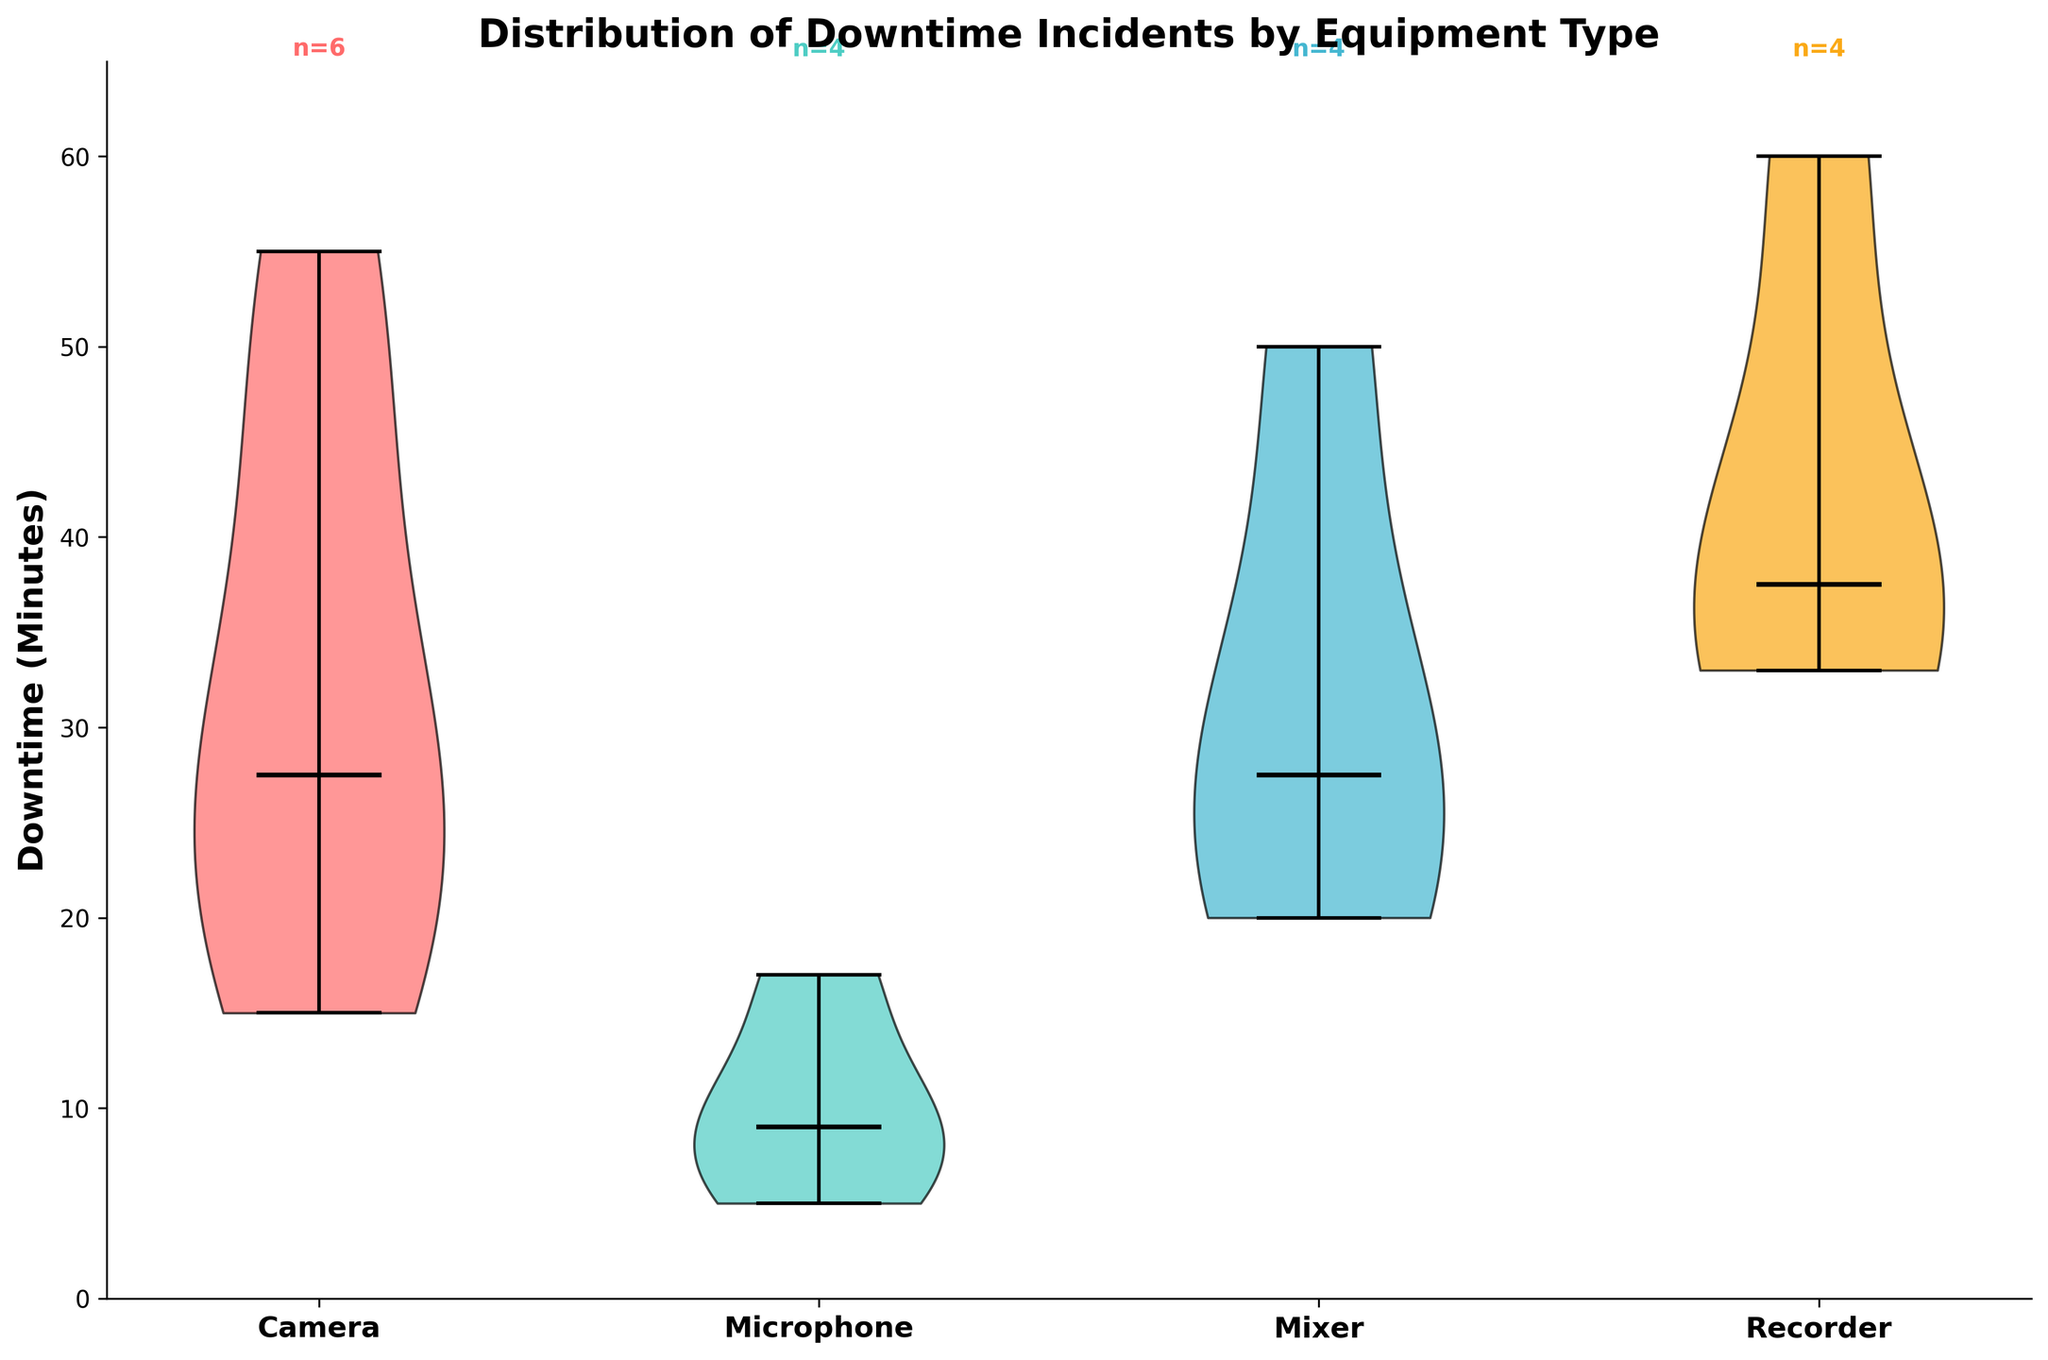What types of equipment are compared in the figure? The equipment types compared are listed on the x-axis of the figure. They are Camera, Microphone, Mixer, and Recorder.
Answer: Camera, Microphone, Mixer, Recorder Which type of equipment has the highest median downtime? The median downtime is represented by the thick black line within each violin plot. The Recorder's violin plot has the highest positioned black line.
Answer: Recorder How many incidents are recorded for Microphones? The number of incidents is indicated by the text above each violin plot. For Microphones, the text above the violin plot reads "n=4".
Answer: 4 Which equipment type shows the widest spread of downtime incidents? The spread of downtime incidents is indicated by the height and shape of the violin plots. The Recorder's plot shows the widest spread.
Answer: Recorder What is the maximum downtime recorded across all equipment types? The y-axis shows the downtime in minutes, and the highest extent of the violins indicates the maximum. The Recorder plot extends to 60 minutes.
Answer: 60 minutes Which type of equipment has downtime incidents clustered mostly around the lower end of the scale? To determine clustering at the lower end, observe where the thickness of the plot is concentrated. For Microphones, most of the data is concentrated near the bottom.
Answer: Microphone How does the median downtime of Camera compare to that of Mixer? Compare the position of the median lines. The Camera plot's median line is positioned lower than the Mixer's median line.
Answer: Camera has a lower median downtime than Mixer What is the general shape of the Camera downtime distribution? The shape can be inferred from the contour of the plot. The Camera downtime distribution shows a wider spread at the center and narrow ends.
Answer: Wide in the middle and narrow at the ends What's the total number of downtime incidents recorded across all equipment types? Sum the number of incidents indicated for each equipment type. Cameras (6) + Microphones (4) + Mixers (4) + Recorders (4) = 18 incidents.
Answer: 18 